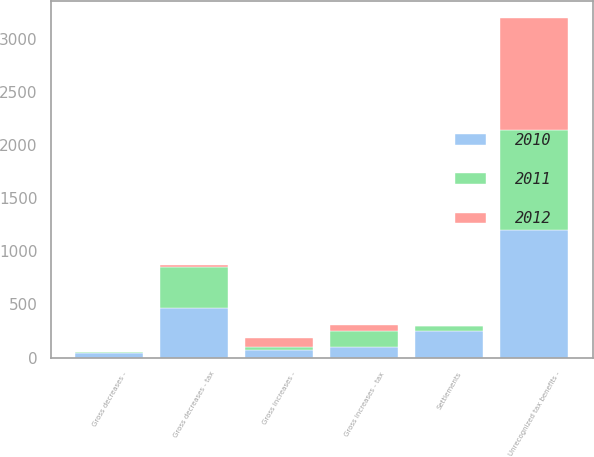<chart> <loc_0><loc_0><loc_500><loc_500><stacked_bar_chart><ecel><fcel>Unrecognized tax benefits -<fcel>Gross increases - tax<fcel>Gross decreases - tax<fcel>Gross increases -<fcel>Gross decreases -<fcel>Settlements<nl><fcel>2012<fcel>1055<fcel>55<fcel>20<fcel>83<fcel>1<fcel>1<nl><fcel>2011<fcel>939<fcel>154<fcel>383<fcel>28<fcel>15<fcel>42<nl><fcel>2010<fcel>1198<fcel>95<fcel>465<fcel>76<fcel>40<fcel>254<nl></chart> 